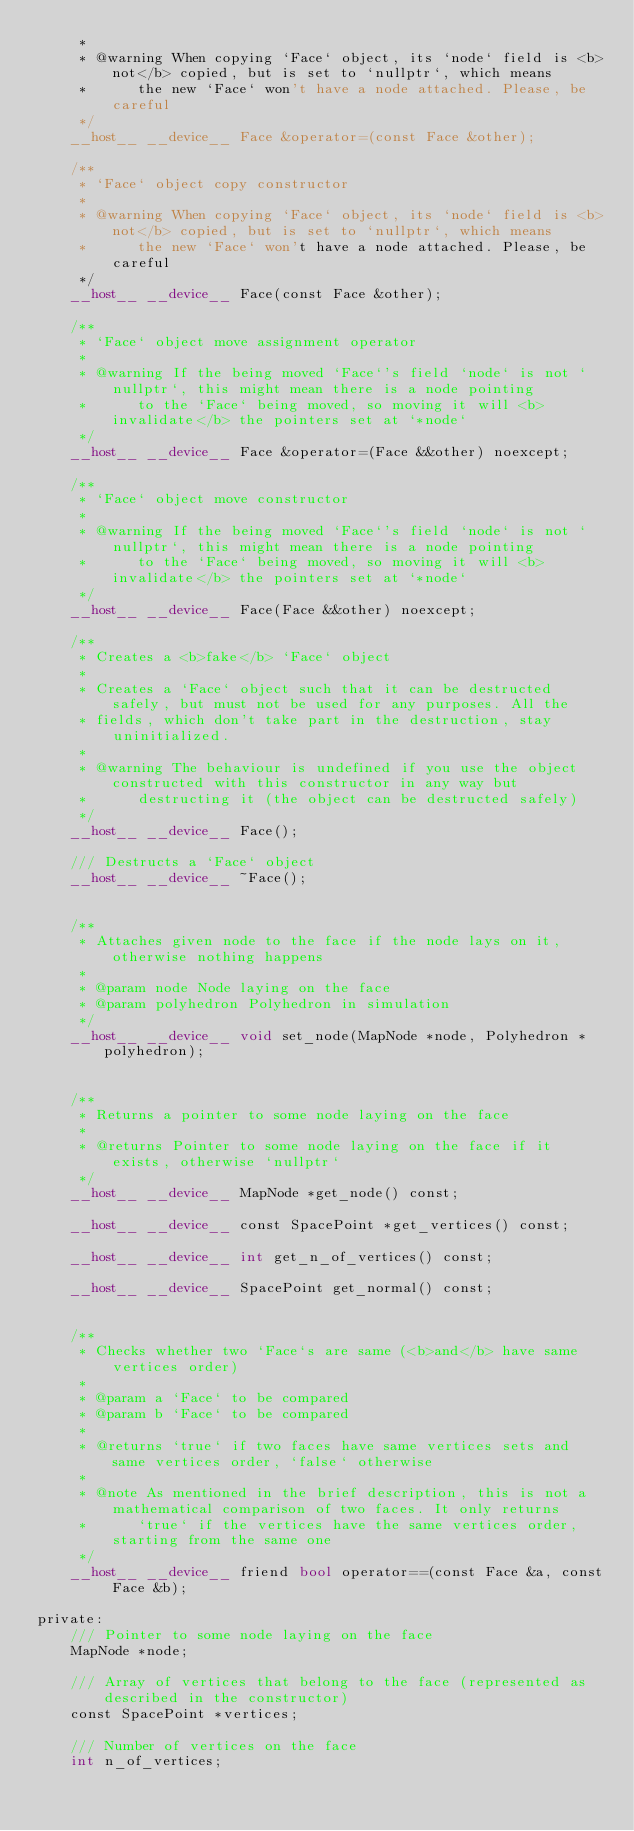<code> <loc_0><loc_0><loc_500><loc_500><_Cuda_>     *
     * @warning When copying `Face` object, its `node` field is <b>not</b> copied, but is set to `nullptr`, which means
     *      the new `Face` won't have a node attached. Please, be careful
     */
    __host__ __device__ Face &operator=(const Face &other);

    /**
     * `Face` object copy constructor
     *
     * @warning When copying `Face` object, its `node` field is <b>not</b> copied, but is set to `nullptr`, which means
     *      the new `Face` won't have a node attached. Please, be careful
     */
    __host__ __device__ Face(const Face &other);

    /**
     * `Face` object move assignment operator
     *
     * @warning If the being moved `Face`'s field `node` is not `nullptr`, this might mean there is a node pointing
     *      to the `Face` being moved, so moving it will <b>invalidate</b> the pointers set at `*node`
     */
    __host__ __device__ Face &operator=(Face &&other) noexcept;

    /**
     * `Face` object move constructor
     *
     * @warning If the being moved `Face`'s field `node` is not `nullptr`, this might mean there is a node pointing
     *      to the `Face` being moved, so moving it will <b>invalidate</b> the pointers set at `*node`
     */
    __host__ __device__ Face(Face &&other) noexcept;

    /**
     * Creates a <b>fake</b> `Face` object
     *
     * Creates a `Face` object such that it can be destructed safely, but must not be used for any purposes. All the
     * fields, which don't take part in the destruction, stay uninitialized.
     *
     * @warning The behaviour is undefined if you use the object constructed with this constructor in any way but
     *      destructing it (the object can be destructed safely)
     */
    __host__ __device__ Face();

    /// Destructs a `Face` object
    __host__ __device__ ~Face();


    /**
     * Attaches given node to the face if the node lays on it, otherwise nothing happens
     *
     * @param node Node laying on the face
     * @param polyhedron Polyhedron in simulation
     */
    __host__ __device__ void set_node(MapNode *node, Polyhedron *polyhedron);


    /**
     * Returns a pointer to some node laying on the face
     *
     * @returns Pointer to some node laying on the face if it exists, otherwise `nullptr`
     */
    __host__ __device__ MapNode *get_node() const;

    __host__ __device__ const SpacePoint *get_vertices() const;

    __host__ __device__ int get_n_of_vertices() const;

    __host__ __device__ SpacePoint get_normal() const;


    /**
     * Checks whether two `Face`s are same (<b>and</b> have same vertices order)
     *
     * @param a `Face` to be compared
     * @param b `Face` to be compared
     *
     * @returns `true` if two faces have same vertices sets and same vertices order, `false` otherwise
     *
     * @note As mentioned in the brief description, this is not a mathematical comparison of two faces. It only returns
     *      `true` if the vertices have the same vertices order, starting from the same one
     */
    __host__ __device__ friend bool operator==(const Face &a, const Face &b);

private:
    /// Pointer to some node laying on the face
    MapNode *node;

    /// Array of vertices that belong to the face (represented as described in the constructor)
    const SpacePoint *vertices;

    /// Number of vertices on the face
    int n_of_vertices;
</code> 